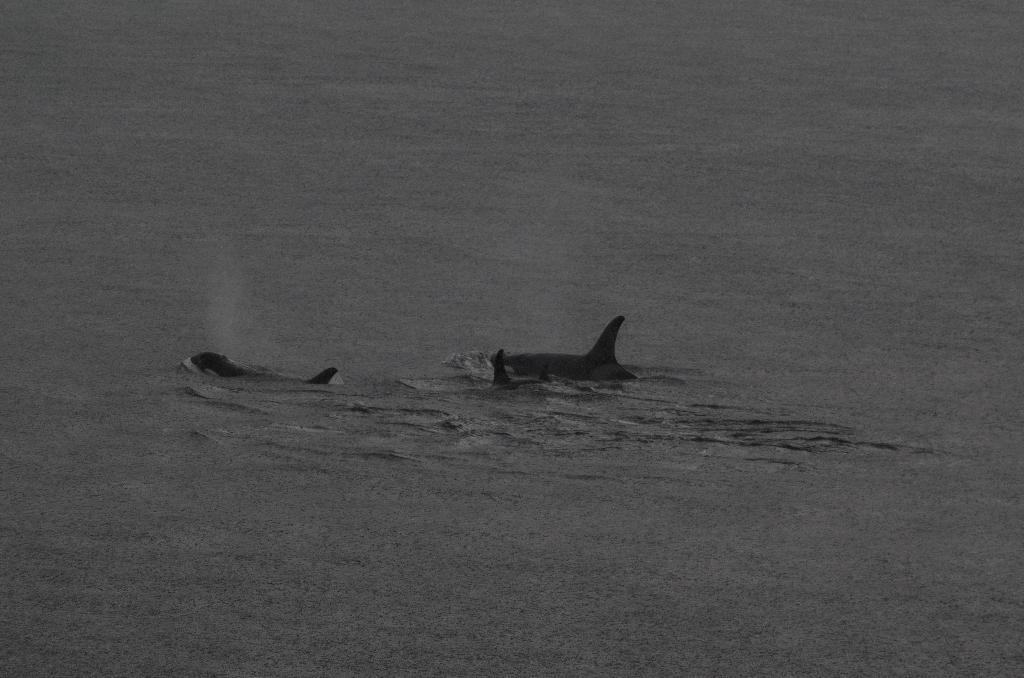What type of animals can be seen in the water in the image? There are sharks in the water in the image. Can you describe the background of the image? The background of the image is blurred. What language is being spoken by the sharks in the image? There is no indication in the image that the sharks are speaking any language. 